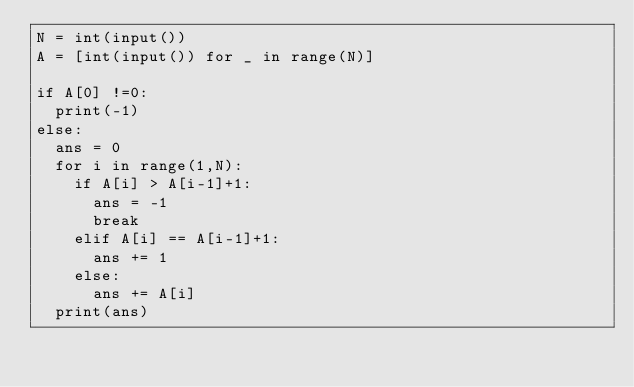<code> <loc_0><loc_0><loc_500><loc_500><_Python_>N = int(input())
A = [int(input()) for _ in range(N)]

if A[0] !=0:
  print(-1)
else:
  ans = 0
  for i in range(1,N):
    if A[i] > A[i-1]+1:
      ans = -1
      break
    elif A[i] == A[i-1]+1:
      ans += 1
    else:
      ans += A[i]
  print(ans)
  </code> 